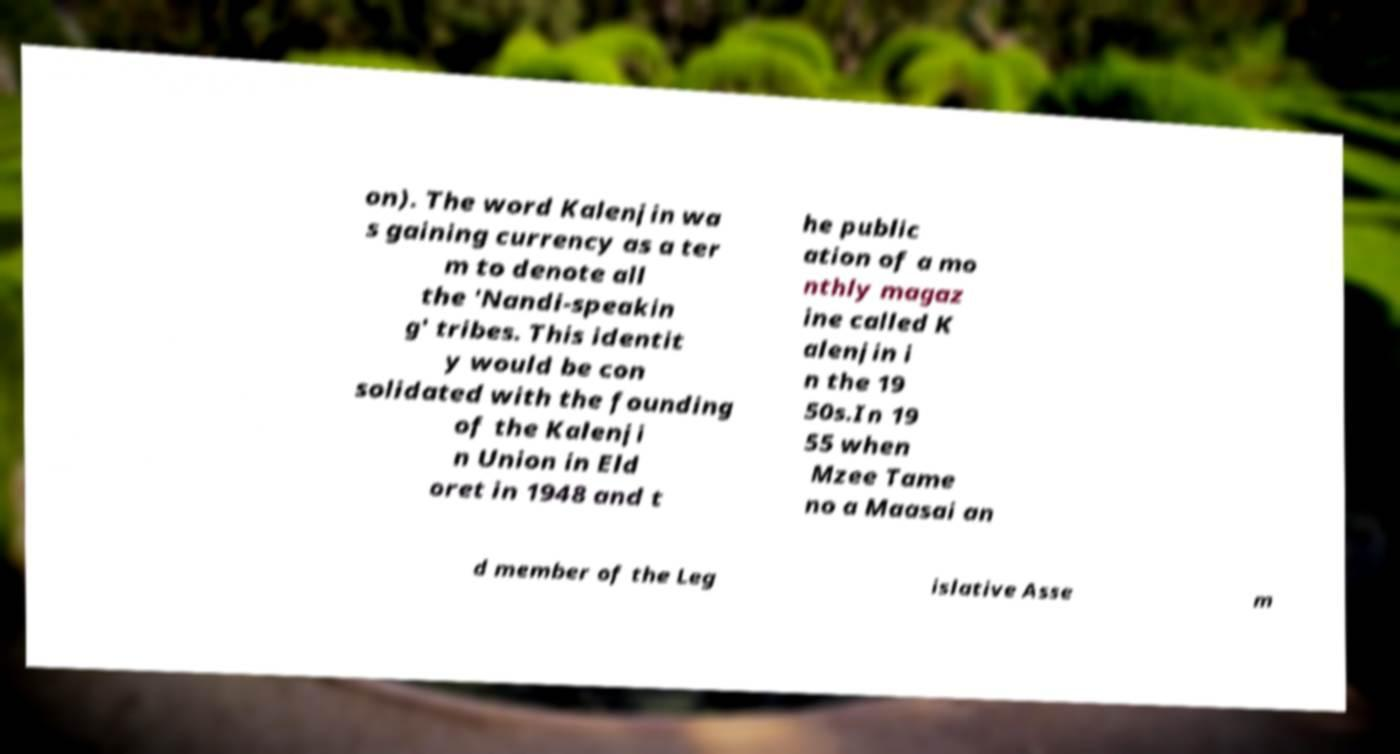For documentation purposes, I need the text within this image transcribed. Could you provide that? on). The word Kalenjin wa s gaining currency as a ter m to denote all the 'Nandi-speakin g' tribes. This identit y would be con solidated with the founding of the Kalenji n Union in Eld oret in 1948 and t he public ation of a mo nthly magaz ine called K alenjin i n the 19 50s.In 19 55 when Mzee Tame no a Maasai an d member of the Leg islative Asse m 